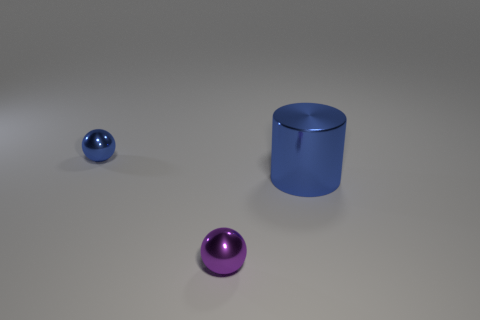Subtract all red balls. Subtract all gray cylinders. How many balls are left? 2 Subtract all purple spheres. How many brown cylinders are left? 0 Add 1 objects. How many small blues exist? 0 Subtract all spheres. Subtract all big gray metallic objects. How many objects are left? 1 Add 1 purple things. How many purple things are left? 2 Add 3 yellow metal cubes. How many yellow metal cubes exist? 3 Add 3 rubber blocks. How many objects exist? 6 Subtract all blue spheres. How many spheres are left? 1 Subtract 0 purple cubes. How many objects are left? 3 Subtract all cylinders. How many objects are left? 2 